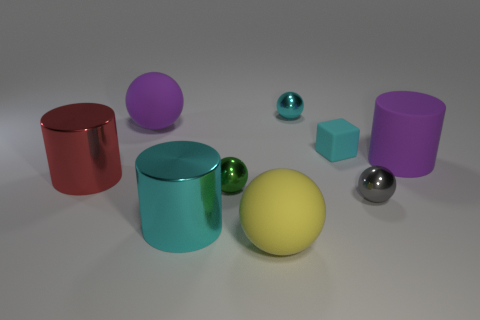Subtract all gray balls. How many balls are left? 4 Subtract all purple matte balls. How many balls are left? 4 Subtract all brown balls. Subtract all yellow cubes. How many balls are left? 5 Add 1 blocks. How many objects exist? 10 Subtract all cubes. How many objects are left? 8 Add 9 green shiny spheres. How many green shiny spheres exist? 10 Subtract 0 blue cylinders. How many objects are left? 9 Subtract all big red shiny cylinders. Subtract all cubes. How many objects are left? 7 Add 1 large purple rubber balls. How many large purple rubber balls are left? 2 